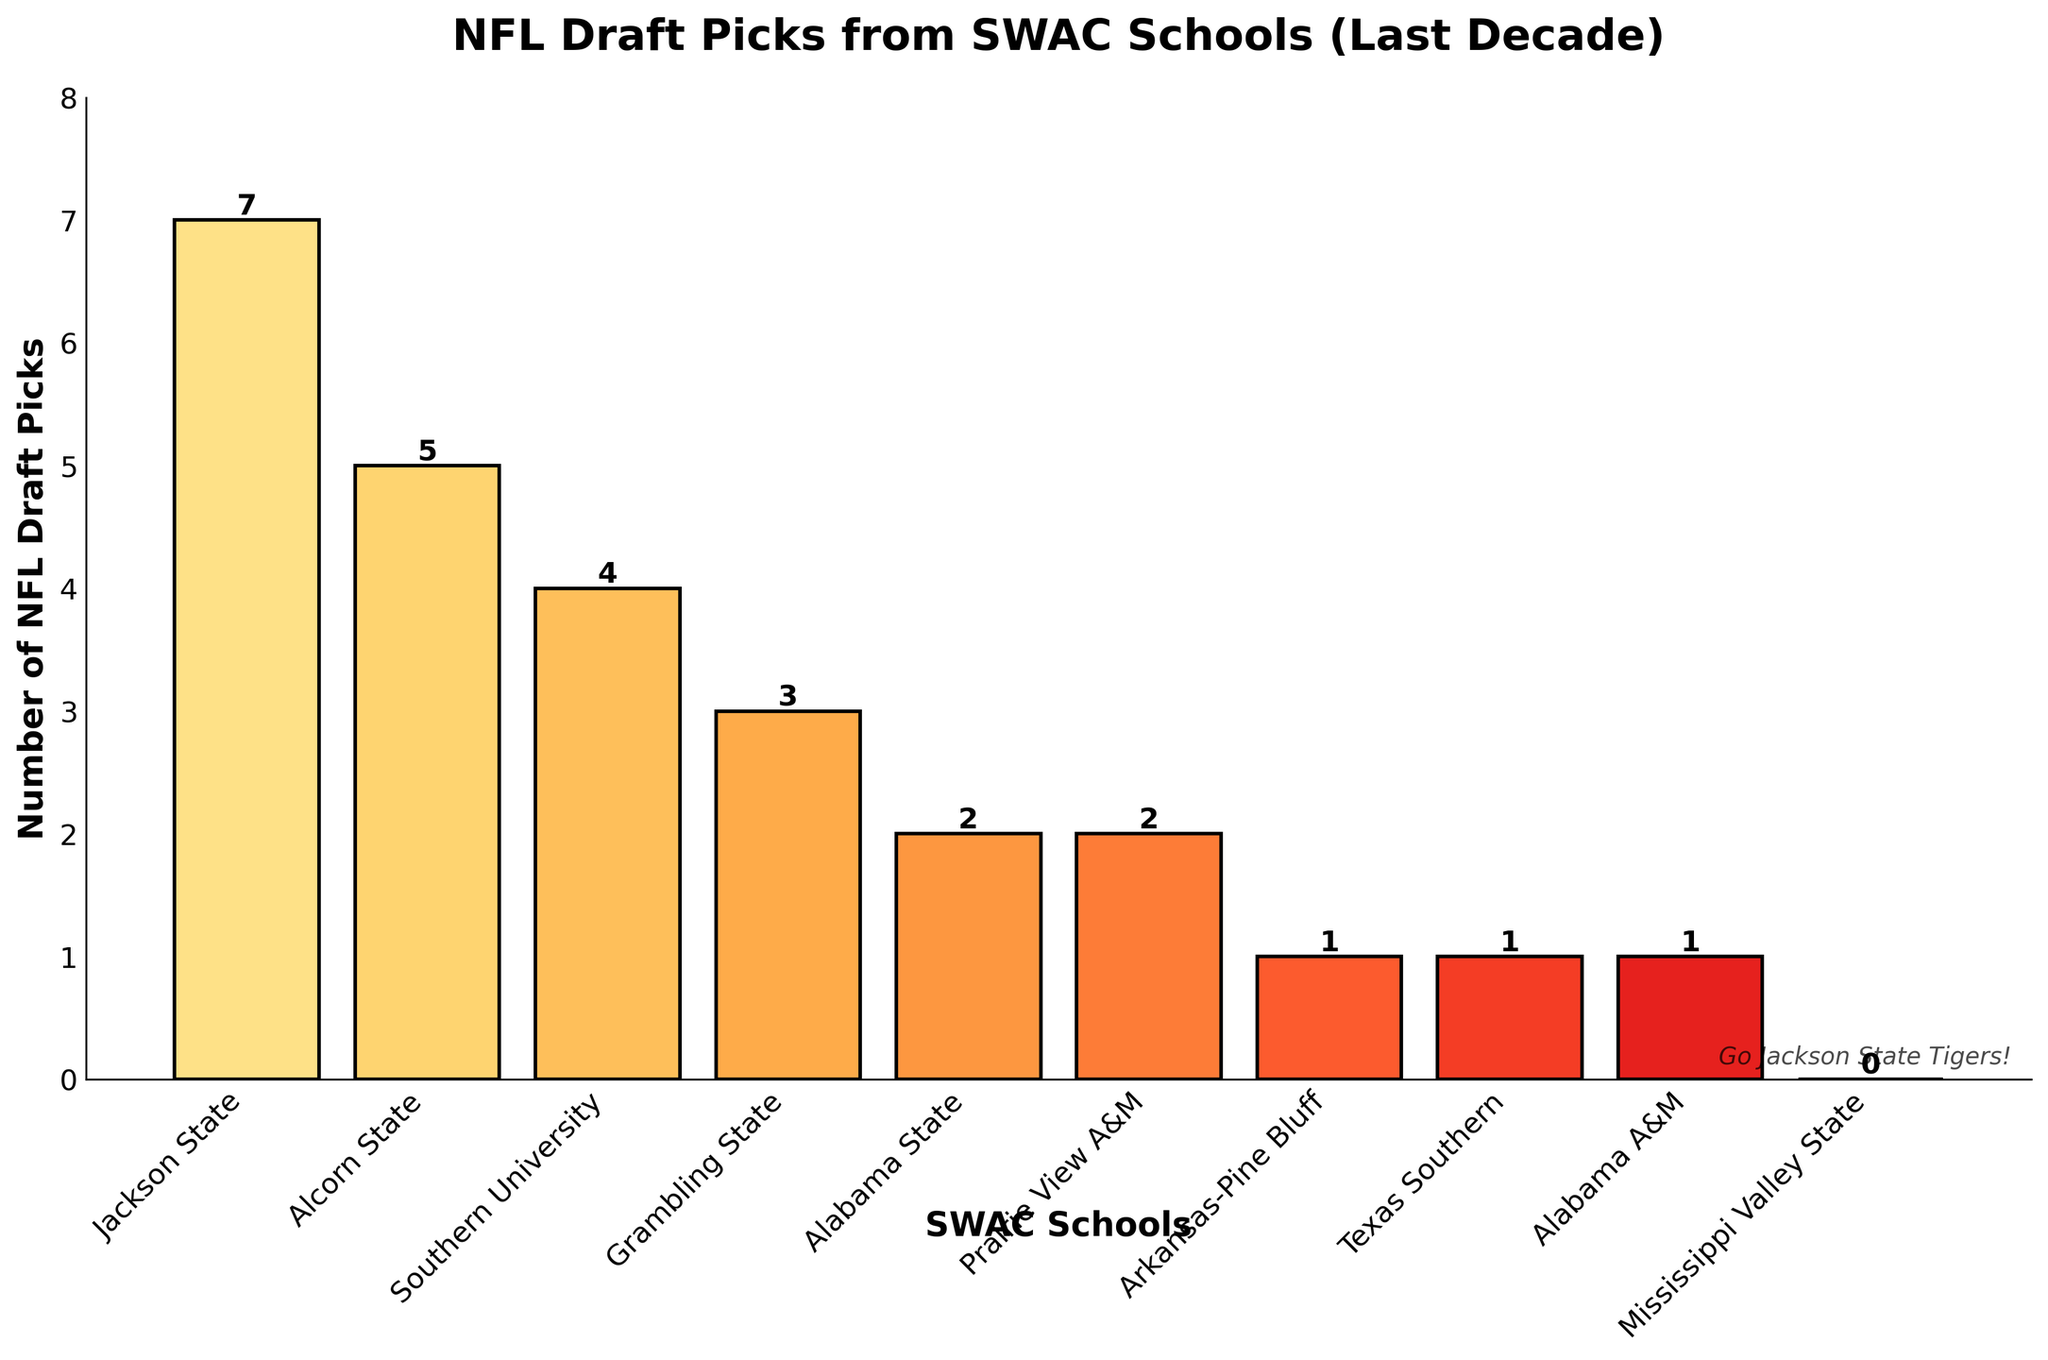What's the total number of NFL draft picks from all SWAC schools combined? Sum up all the draft picks from each team: 7 (Jackson State) + 5 (Alcorn State) + 4 (Southern University) + 3 (Grambling State) + 2 (Alabama State) + 2 (Prairie View A&M) + 1 (Arkansas-Pine Bluff) + 1 (Texas Southern) + 1 (Alabama A&M) + 0 (Mississippi Valley State) = 26
Answer: 26 Which team has the most NFL draft picks? Look for the tallest bar in the bar chart, which represents Jackson State with 7 draft picks
Answer: Jackson State What's the difference in NFL draft picks between Jackson State and Southern University? Jackson State has 7 picks and Southern University has 4 picks, so the difference is 7 - 4 = 3
Answer: 3 How many more NFL draft picks does Alcorn State have compared to Arkansas-Pine Bluff? Alcorn State has 5 picks and Arkansas-Pine Bluff has 1 pick, so the difference is 5 - 1 = 4
Answer: 4 Which teams have the same number of NFL draft picks? Identify bars with the same height: Alabama State and Prairie View A&M each have 2 picks, Arkansas-Pine Bluff, Texas Southern, and Alabama A&M each have 1 pick
Answer: Alabama State and Prairie View A&M; Arkansas-Pine Bluff, Texas Southern, and Alabama A&M What's the average number of NFL draft picks for the teams that have more than 3 picks? Teams with more than 3 picks are Jackson State (7), Alcorn State (5), and Southern University (4). Sum = 7 + 5 + 4 = 16. Number of teams = 3. Average = 16 / 3 = 5.33
Answer: 5.33 How many teams have at least 1 NFL draft pick? Exclude Mississippi Valley State, which has 0 picks. So, 9 teams have at least 1 pick: Jackson State, Alcorn State, Southern University, Grambling State, Alabama State, Prairie View A&M, Arkansas-Pine Bluff, Texas Southern, Alabama A&M
Answer: 9 Which team has the least NFL draft picks, and how many? Look for the shortest bar with a non-zero value, which represents Arkansas-Pine Bluff, Texas Southern, and Alabama A&M each with 1 pick
Answer: Arkansas-Pine Bluff, Texas Southern, and Alabama A&M; 1 What is the combined total of draft picks for the teams with exactly 2 picks each? Alabama State and Prairie View A&M each have 2 picks. Sum = 2 + 2 = 4
Answer: 4 